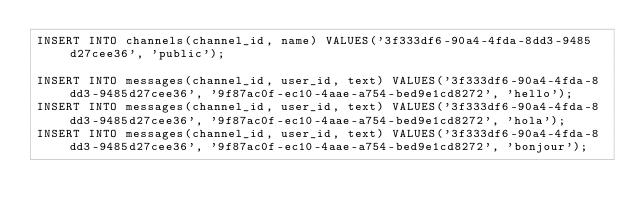<code> <loc_0><loc_0><loc_500><loc_500><_SQL_>INSERT INTO channels(channel_id, name) VALUES('3f333df6-90a4-4fda-8dd3-9485d27cee36', 'public');

INSERT INTO messages(channel_id, user_id, text) VALUES('3f333df6-90a4-4fda-8dd3-9485d27cee36', '9f87ac0f-ec10-4aae-a754-bed9e1cd8272', 'hello');
INSERT INTO messages(channel_id, user_id, text) VALUES('3f333df6-90a4-4fda-8dd3-9485d27cee36', '9f87ac0f-ec10-4aae-a754-bed9e1cd8272', 'hola');
INSERT INTO messages(channel_id, user_id, text) VALUES('3f333df6-90a4-4fda-8dd3-9485d27cee36', '9f87ac0f-ec10-4aae-a754-bed9e1cd8272', 'bonjour');
</code> 